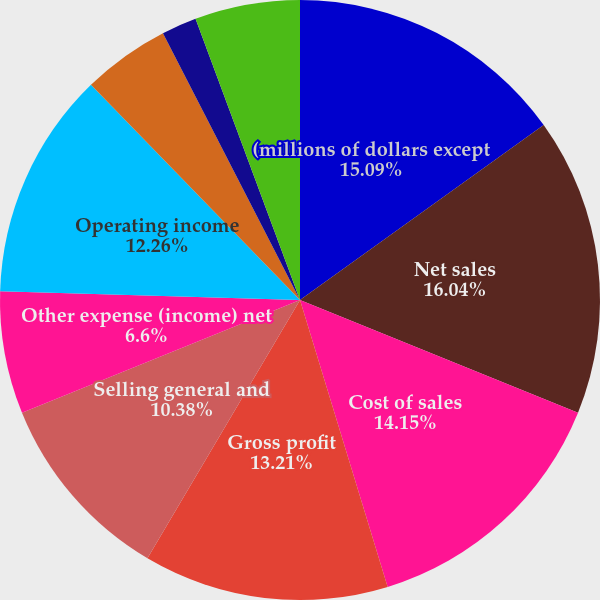Convert chart. <chart><loc_0><loc_0><loc_500><loc_500><pie_chart><fcel>(millions of dollars except<fcel>Net sales<fcel>Cost of sales<fcel>Gross profit<fcel>Selling general and<fcel>Other expense (income) net<fcel>Operating income<fcel>Equity in affiliates' earnings<fcel>Interest income<fcel>Interest expense and finance<nl><fcel>15.09%<fcel>16.04%<fcel>14.15%<fcel>13.21%<fcel>10.38%<fcel>6.6%<fcel>12.26%<fcel>4.72%<fcel>1.89%<fcel>5.66%<nl></chart> 